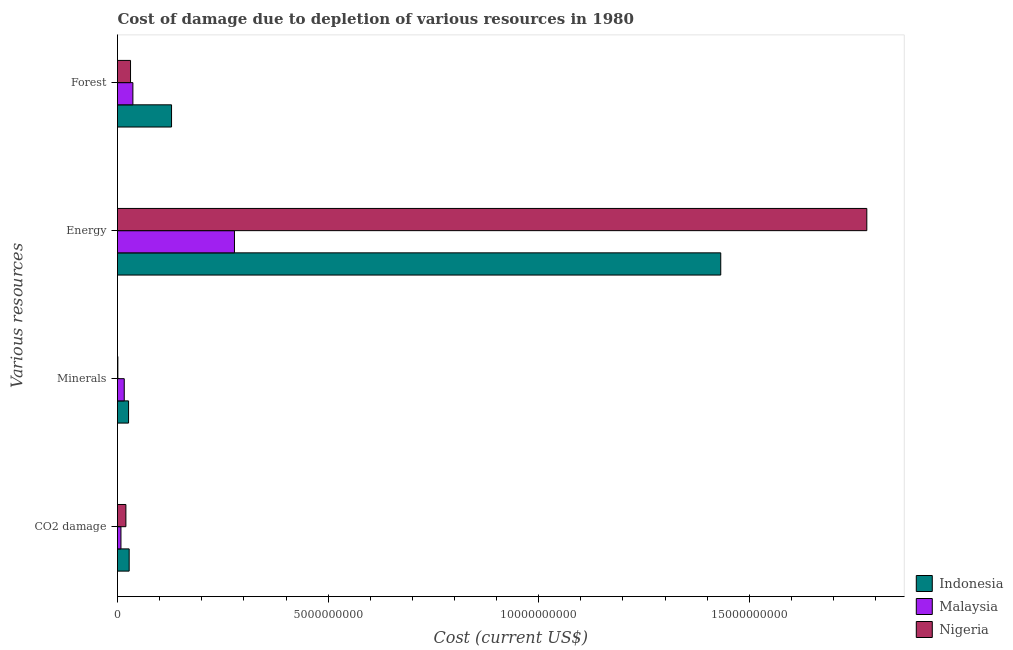How many different coloured bars are there?
Offer a very short reply. 3. How many groups of bars are there?
Your answer should be very brief. 4. Are the number of bars per tick equal to the number of legend labels?
Give a very brief answer. Yes. What is the label of the 4th group of bars from the top?
Provide a succinct answer. CO2 damage. What is the cost of damage due to depletion of minerals in Malaysia?
Ensure brevity in your answer.  1.60e+08. Across all countries, what is the maximum cost of damage due to depletion of energy?
Provide a succinct answer. 1.78e+1. Across all countries, what is the minimum cost of damage due to depletion of minerals?
Make the answer very short. 8.49e+06. In which country was the cost of damage due to depletion of minerals maximum?
Offer a terse response. Indonesia. In which country was the cost of damage due to depletion of coal minimum?
Make the answer very short. Malaysia. What is the total cost of damage due to depletion of minerals in the graph?
Provide a succinct answer. 4.31e+08. What is the difference between the cost of damage due to depletion of minerals in Nigeria and that in Malaysia?
Your answer should be compact. -1.52e+08. What is the difference between the cost of damage due to depletion of forests in Indonesia and the cost of damage due to depletion of coal in Nigeria?
Provide a succinct answer. 1.08e+09. What is the average cost of damage due to depletion of forests per country?
Keep it short and to the point. 6.52e+08. What is the difference between the cost of damage due to depletion of forests and cost of damage due to depletion of energy in Malaysia?
Make the answer very short. -2.41e+09. In how many countries, is the cost of damage due to depletion of forests greater than 15000000000 US$?
Offer a very short reply. 0. What is the ratio of the cost of damage due to depletion of forests in Nigeria to that in Malaysia?
Keep it short and to the point. 0.85. What is the difference between the highest and the second highest cost of damage due to depletion of coal?
Your response must be concise. 7.78e+07. What is the difference between the highest and the lowest cost of damage due to depletion of energy?
Your answer should be compact. 1.50e+1. In how many countries, is the cost of damage due to depletion of energy greater than the average cost of damage due to depletion of energy taken over all countries?
Your answer should be compact. 2. What does the 3rd bar from the top in Energy represents?
Your answer should be compact. Indonesia. What does the 3rd bar from the bottom in Minerals represents?
Keep it short and to the point. Nigeria. How many bars are there?
Make the answer very short. 12. How many countries are there in the graph?
Keep it short and to the point. 3. Does the graph contain any zero values?
Offer a terse response. No. Does the graph contain grids?
Ensure brevity in your answer.  No. How are the legend labels stacked?
Offer a very short reply. Vertical. What is the title of the graph?
Offer a terse response. Cost of damage due to depletion of various resources in 1980 . Does "American Samoa" appear as one of the legend labels in the graph?
Provide a short and direct response. No. What is the label or title of the X-axis?
Your answer should be very brief. Cost (current US$). What is the label or title of the Y-axis?
Your response must be concise. Various resources. What is the Cost (current US$) of Indonesia in CO2 damage?
Your answer should be very brief. 2.77e+08. What is the Cost (current US$) of Malaysia in CO2 damage?
Your answer should be very brief. 8.18e+07. What is the Cost (current US$) in Nigeria in CO2 damage?
Your answer should be very brief. 1.99e+08. What is the Cost (current US$) of Indonesia in Minerals?
Your answer should be very brief. 2.62e+08. What is the Cost (current US$) in Malaysia in Minerals?
Provide a succinct answer. 1.60e+08. What is the Cost (current US$) in Nigeria in Minerals?
Ensure brevity in your answer.  8.49e+06. What is the Cost (current US$) of Indonesia in Energy?
Offer a terse response. 1.43e+1. What is the Cost (current US$) of Malaysia in Energy?
Give a very brief answer. 2.78e+09. What is the Cost (current US$) of Nigeria in Energy?
Make the answer very short. 1.78e+1. What is the Cost (current US$) in Indonesia in Forest?
Make the answer very short. 1.28e+09. What is the Cost (current US$) of Malaysia in Forest?
Keep it short and to the point. 3.65e+08. What is the Cost (current US$) of Nigeria in Forest?
Your answer should be compact. 3.09e+08. Across all Various resources, what is the maximum Cost (current US$) of Indonesia?
Your response must be concise. 1.43e+1. Across all Various resources, what is the maximum Cost (current US$) in Malaysia?
Keep it short and to the point. 2.78e+09. Across all Various resources, what is the maximum Cost (current US$) of Nigeria?
Offer a very short reply. 1.78e+1. Across all Various resources, what is the minimum Cost (current US$) of Indonesia?
Offer a terse response. 2.62e+08. Across all Various resources, what is the minimum Cost (current US$) in Malaysia?
Offer a very short reply. 8.18e+07. Across all Various resources, what is the minimum Cost (current US$) in Nigeria?
Provide a succinct answer. 8.49e+06. What is the total Cost (current US$) of Indonesia in the graph?
Your response must be concise. 1.61e+1. What is the total Cost (current US$) in Malaysia in the graph?
Provide a short and direct response. 3.38e+09. What is the total Cost (current US$) of Nigeria in the graph?
Your answer should be compact. 1.83e+1. What is the difference between the Cost (current US$) in Indonesia in CO2 damage and that in Minerals?
Your response must be concise. 1.45e+07. What is the difference between the Cost (current US$) in Malaysia in CO2 damage and that in Minerals?
Keep it short and to the point. -7.84e+07. What is the difference between the Cost (current US$) in Nigeria in CO2 damage and that in Minerals?
Your answer should be compact. 1.91e+08. What is the difference between the Cost (current US$) in Indonesia in CO2 damage and that in Energy?
Your answer should be compact. -1.40e+1. What is the difference between the Cost (current US$) in Malaysia in CO2 damage and that in Energy?
Offer a very short reply. -2.69e+09. What is the difference between the Cost (current US$) in Nigeria in CO2 damage and that in Energy?
Offer a terse response. -1.76e+1. What is the difference between the Cost (current US$) in Indonesia in CO2 damage and that in Forest?
Your answer should be compact. -1.01e+09. What is the difference between the Cost (current US$) in Malaysia in CO2 damage and that in Forest?
Your response must be concise. -2.84e+08. What is the difference between the Cost (current US$) in Nigeria in CO2 damage and that in Forest?
Provide a succinct answer. -1.10e+08. What is the difference between the Cost (current US$) of Indonesia in Minerals and that in Energy?
Provide a succinct answer. -1.41e+1. What is the difference between the Cost (current US$) of Malaysia in Minerals and that in Energy?
Give a very brief answer. -2.62e+09. What is the difference between the Cost (current US$) of Nigeria in Minerals and that in Energy?
Offer a very short reply. -1.78e+1. What is the difference between the Cost (current US$) of Indonesia in Minerals and that in Forest?
Give a very brief answer. -1.02e+09. What is the difference between the Cost (current US$) of Malaysia in Minerals and that in Forest?
Keep it short and to the point. -2.05e+08. What is the difference between the Cost (current US$) in Nigeria in Minerals and that in Forest?
Your answer should be very brief. -3.01e+08. What is the difference between the Cost (current US$) in Indonesia in Energy and that in Forest?
Provide a short and direct response. 1.30e+1. What is the difference between the Cost (current US$) of Malaysia in Energy and that in Forest?
Provide a succinct answer. 2.41e+09. What is the difference between the Cost (current US$) in Nigeria in Energy and that in Forest?
Provide a short and direct response. 1.75e+1. What is the difference between the Cost (current US$) in Indonesia in CO2 damage and the Cost (current US$) in Malaysia in Minerals?
Offer a terse response. 1.17e+08. What is the difference between the Cost (current US$) in Indonesia in CO2 damage and the Cost (current US$) in Nigeria in Minerals?
Keep it short and to the point. 2.68e+08. What is the difference between the Cost (current US$) in Malaysia in CO2 damage and the Cost (current US$) in Nigeria in Minerals?
Give a very brief answer. 7.33e+07. What is the difference between the Cost (current US$) in Indonesia in CO2 damage and the Cost (current US$) in Malaysia in Energy?
Make the answer very short. -2.50e+09. What is the difference between the Cost (current US$) in Indonesia in CO2 damage and the Cost (current US$) in Nigeria in Energy?
Give a very brief answer. -1.75e+1. What is the difference between the Cost (current US$) of Malaysia in CO2 damage and the Cost (current US$) of Nigeria in Energy?
Provide a succinct answer. -1.77e+1. What is the difference between the Cost (current US$) of Indonesia in CO2 damage and the Cost (current US$) of Malaysia in Forest?
Provide a short and direct response. -8.84e+07. What is the difference between the Cost (current US$) in Indonesia in CO2 damage and the Cost (current US$) in Nigeria in Forest?
Provide a succinct answer. -3.22e+07. What is the difference between the Cost (current US$) in Malaysia in CO2 damage and the Cost (current US$) in Nigeria in Forest?
Your answer should be very brief. -2.27e+08. What is the difference between the Cost (current US$) in Indonesia in Minerals and the Cost (current US$) in Malaysia in Energy?
Provide a succinct answer. -2.51e+09. What is the difference between the Cost (current US$) of Indonesia in Minerals and the Cost (current US$) of Nigeria in Energy?
Your answer should be compact. -1.75e+1. What is the difference between the Cost (current US$) in Malaysia in Minerals and the Cost (current US$) in Nigeria in Energy?
Provide a short and direct response. -1.76e+1. What is the difference between the Cost (current US$) in Indonesia in Minerals and the Cost (current US$) in Malaysia in Forest?
Provide a short and direct response. -1.03e+08. What is the difference between the Cost (current US$) in Indonesia in Minerals and the Cost (current US$) in Nigeria in Forest?
Give a very brief answer. -4.67e+07. What is the difference between the Cost (current US$) in Malaysia in Minerals and the Cost (current US$) in Nigeria in Forest?
Give a very brief answer. -1.49e+08. What is the difference between the Cost (current US$) in Indonesia in Energy and the Cost (current US$) in Malaysia in Forest?
Keep it short and to the point. 1.40e+1. What is the difference between the Cost (current US$) of Indonesia in Energy and the Cost (current US$) of Nigeria in Forest?
Provide a short and direct response. 1.40e+1. What is the difference between the Cost (current US$) of Malaysia in Energy and the Cost (current US$) of Nigeria in Forest?
Keep it short and to the point. 2.47e+09. What is the average Cost (current US$) of Indonesia per Various resources?
Your answer should be very brief. 4.04e+09. What is the average Cost (current US$) of Malaysia per Various resources?
Ensure brevity in your answer.  8.46e+08. What is the average Cost (current US$) of Nigeria per Various resources?
Give a very brief answer. 4.58e+09. What is the difference between the Cost (current US$) in Indonesia and Cost (current US$) in Malaysia in CO2 damage?
Provide a short and direct response. 1.95e+08. What is the difference between the Cost (current US$) of Indonesia and Cost (current US$) of Nigeria in CO2 damage?
Offer a very short reply. 7.78e+07. What is the difference between the Cost (current US$) in Malaysia and Cost (current US$) in Nigeria in CO2 damage?
Keep it short and to the point. -1.17e+08. What is the difference between the Cost (current US$) of Indonesia and Cost (current US$) of Malaysia in Minerals?
Your answer should be very brief. 1.02e+08. What is the difference between the Cost (current US$) of Indonesia and Cost (current US$) of Nigeria in Minerals?
Your response must be concise. 2.54e+08. What is the difference between the Cost (current US$) in Malaysia and Cost (current US$) in Nigeria in Minerals?
Your answer should be very brief. 1.52e+08. What is the difference between the Cost (current US$) in Indonesia and Cost (current US$) in Malaysia in Energy?
Offer a very short reply. 1.15e+1. What is the difference between the Cost (current US$) of Indonesia and Cost (current US$) of Nigeria in Energy?
Keep it short and to the point. -3.47e+09. What is the difference between the Cost (current US$) in Malaysia and Cost (current US$) in Nigeria in Energy?
Make the answer very short. -1.50e+1. What is the difference between the Cost (current US$) of Indonesia and Cost (current US$) of Malaysia in Forest?
Your response must be concise. 9.18e+08. What is the difference between the Cost (current US$) in Indonesia and Cost (current US$) in Nigeria in Forest?
Provide a succinct answer. 9.74e+08. What is the difference between the Cost (current US$) in Malaysia and Cost (current US$) in Nigeria in Forest?
Ensure brevity in your answer.  5.62e+07. What is the ratio of the Cost (current US$) of Indonesia in CO2 damage to that in Minerals?
Your response must be concise. 1.06. What is the ratio of the Cost (current US$) in Malaysia in CO2 damage to that in Minerals?
Offer a very short reply. 0.51. What is the ratio of the Cost (current US$) of Nigeria in CO2 damage to that in Minerals?
Your answer should be compact. 23.45. What is the ratio of the Cost (current US$) of Indonesia in CO2 damage to that in Energy?
Offer a very short reply. 0.02. What is the ratio of the Cost (current US$) of Malaysia in CO2 damage to that in Energy?
Give a very brief answer. 0.03. What is the ratio of the Cost (current US$) in Nigeria in CO2 damage to that in Energy?
Offer a terse response. 0.01. What is the ratio of the Cost (current US$) in Indonesia in CO2 damage to that in Forest?
Your answer should be very brief. 0.22. What is the ratio of the Cost (current US$) in Malaysia in CO2 damage to that in Forest?
Provide a short and direct response. 0.22. What is the ratio of the Cost (current US$) of Nigeria in CO2 damage to that in Forest?
Ensure brevity in your answer.  0.64. What is the ratio of the Cost (current US$) in Indonesia in Minerals to that in Energy?
Your response must be concise. 0.02. What is the ratio of the Cost (current US$) of Malaysia in Minerals to that in Energy?
Your answer should be very brief. 0.06. What is the ratio of the Cost (current US$) in Nigeria in Minerals to that in Energy?
Provide a short and direct response. 0. What is the ratio of the Cost (current US$) of Indonesia in Minerals to that in Forest?
Make the answer very short. 0.2. What is the ratio of the Cost (current US$) of Malaysia in Minerals to that in Forest?
Your answer should be compact. 0.44. What is the ratio of the Cost (current US$) of Nigeria in Minerals to that in Forest?
Give a very brief answer. 0.03. What is the ratio of the Cost (current US$) in Indonesia in Energy to that in Forest?
Make the answer very short. 11.16. What is the ratio of the Cost (current US$) in Malaysia in Energy to that in Forest?
Ensure brevity in your answer.  7.6. What is the ratio of the Cost (current US$) in Nigeria in Energy to that in Forest?
Your response must be concise. 57.55. What is the difference between the highest and the second highest Cost (current US$) in Indonesia?
Provide a succinct answer. 1.30e+1. What is the difference between the highest and the second highest Cost (current US$) of Malaysia?
Your response must be concise. 2.41e+09. What is the difference between the highest and the second highest Cost (current US$) in Nigeria?
Give a very brief answer. 1.75e+1. What is the difference between the highest and the lowest Cost (current US$) of Indonesia?
Your response must be concise. 1.41e+1. What is the difference between the highest and the lowest Cost (current US$) in Malaysia?
Make the answer very short. 2.69e+09. What is the difference between the highest and the lowest Cost (current US$) in Nigeria?
Keep it short and to the point. 1.78e+1. 